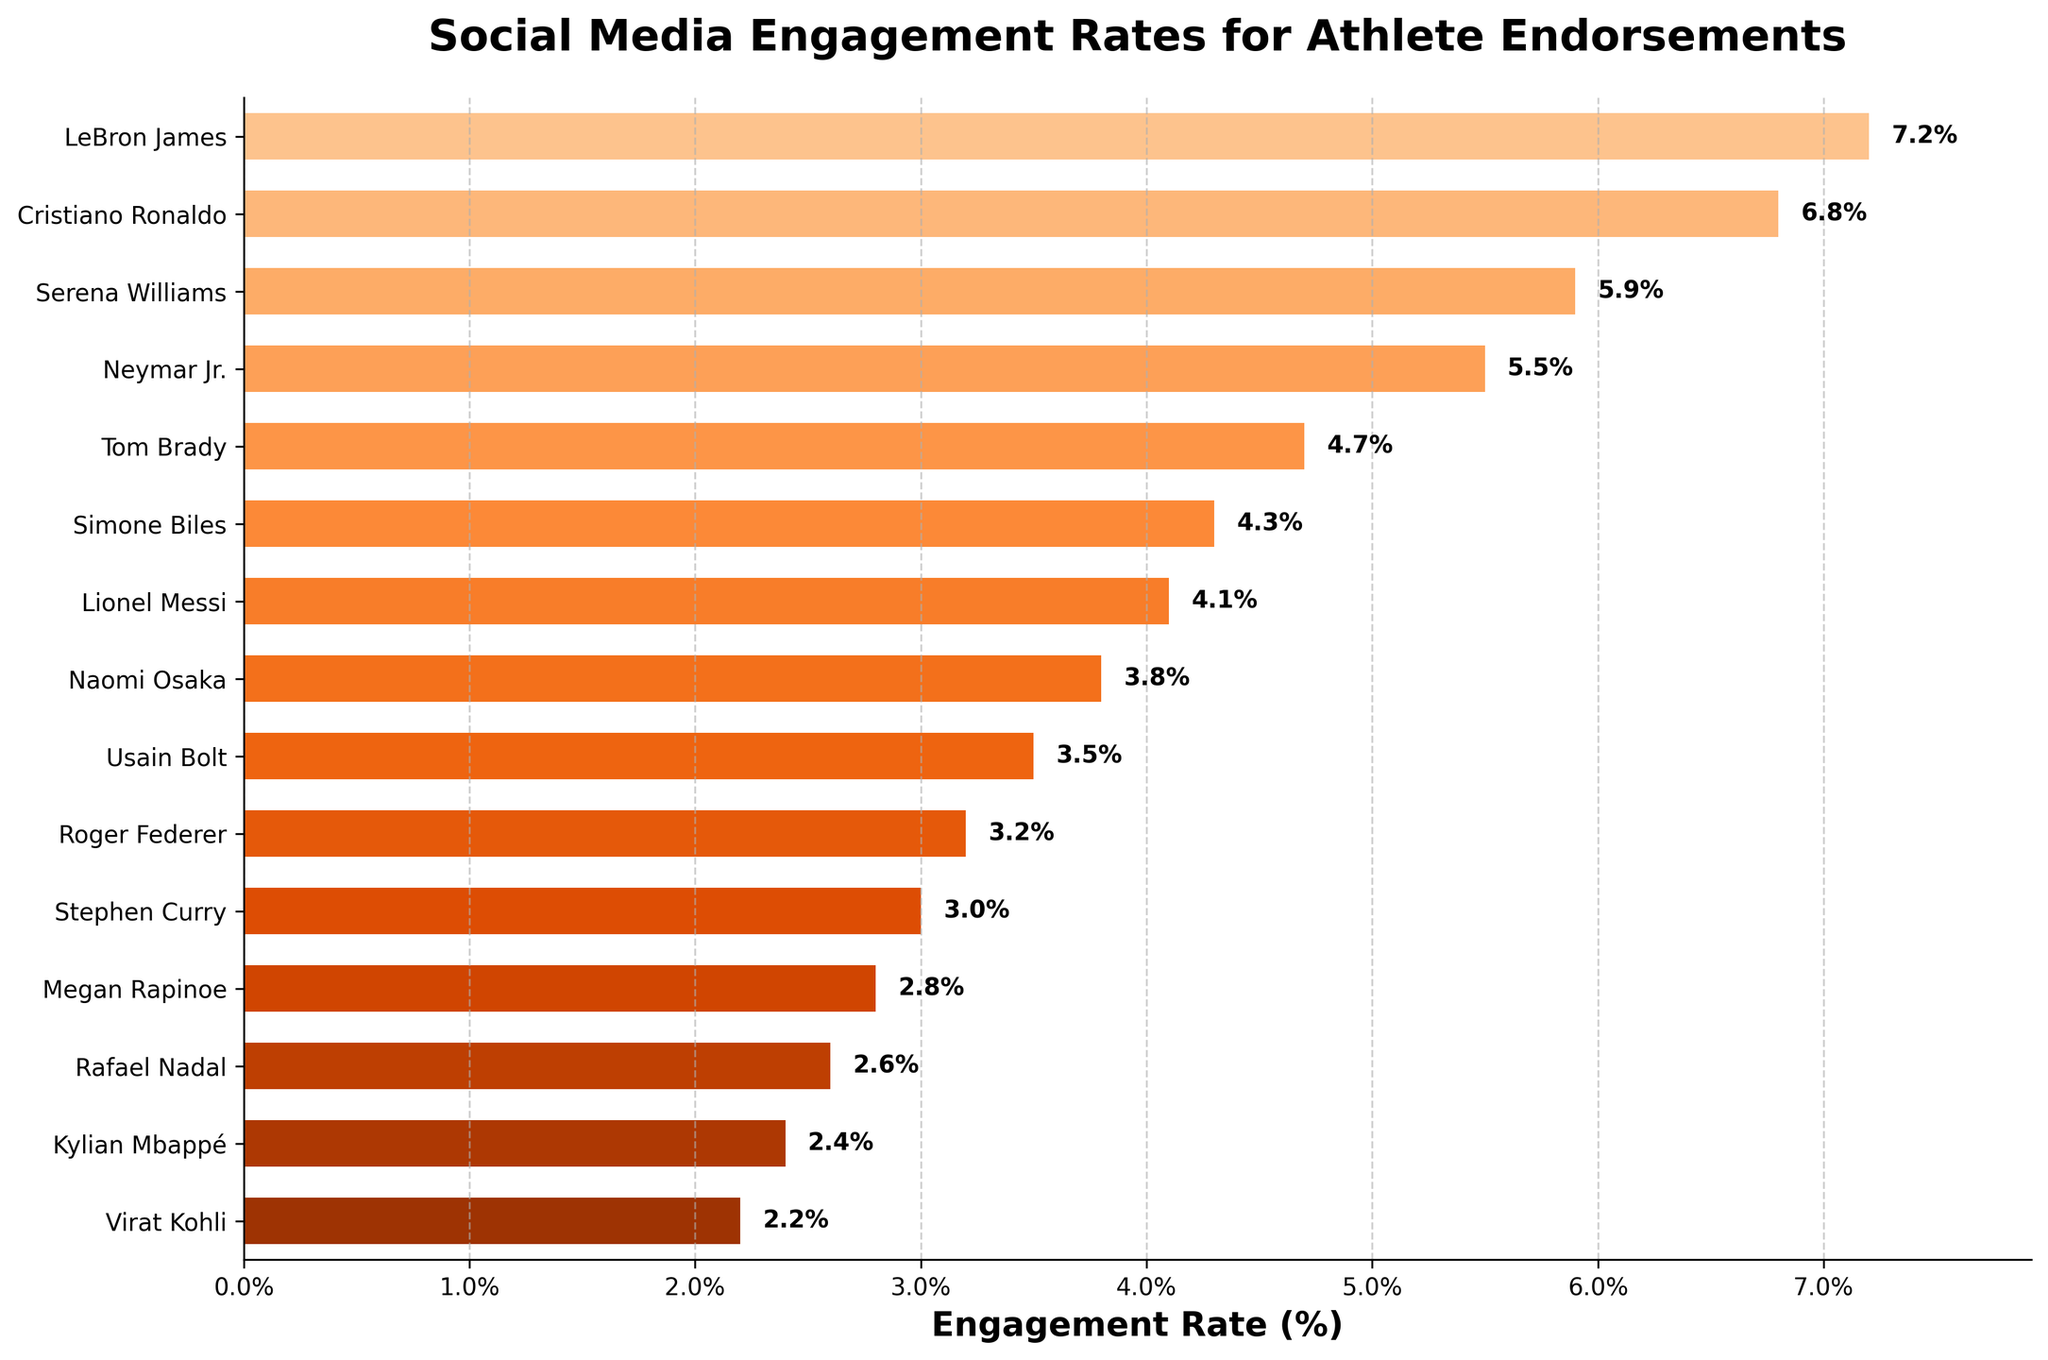What's the engagement rate for Naomi Osaka? To find Naomi Osaka's engagement rate, locate her name on the y-axis and follow horizontally to the corresponding bar. The value is labeled at the end of the bar.
Answer: 3.8% Which athlete has the highest engagement rate? To determine the highest engagement rate, look for the longest bar in the chart. LeBron James has the longest bar.
Answer: LeBron James Who has a higher engagement rate, Serena Williams or Tom Brady? Compare the lengths of the bars for Serena Williams and Tom Brady. Serena Williams' bar is longer.
Answer: Serena Williams What is the difference in engagement rate between Cristiano Ronaldo and Lionel Messi? Locate the bars for Cristiano Ronaldo and Lionel Messi, and subtract Messi's rate (4.1%) from Ronaldo's rate (6.8%).
Answer: 2.7% What's the average engagement rate of the top 5 athletes? Identify the top 5 athletes (LeBron James, Cristiano Ronaldo, Serena Williams, Neymar Jr., Tom Brady) and their rates (7.2, 6.8, 5.9, 5.5, 4.7). Sum these rates and divide by 5: (7.2 + 6.8 + 5.9 + 5.5 + 4.7) / 5 = 30.1 / 5.
Answer: 6.02 How many athletes have an engagement rate higher than 5%? Count the number of bars extending beyond the 5% mark: LeBron James, Cristiano Ronaldo, Serena Williams, and Neymar Jr. There are 4 athletes.
Answer: 4 If Serena Williams' engagement rate increased by 1%, would she still be ranked 3rd? Add 1% to Serena Williams' current rate (5.9% + 1% = 6.9%). Compare this new rate with Cristiano Ronaldo (6.8%) and LeBron James (7.2%). She would rank 2nd.
Answer: No Which athlete has the lowest engagement rate, and what is it? Find the shortest bar on the chart, which belongs to Virat Kohli.
Answer: Virat Kohli, 2.2% What is the average engagement rate across all athletes? Sum all the engagement rates and divide by the total number of athletes (15). Total = 7.2 + 6.8 + 5.9 + 5.5 + 4.7 + 4.3 + 4.1 + 3.8 + 3.5 + 3.2 + 3.0 + 2.8 + 2.6 + 2.4 + 2.2 = 61.0. Average = 61.0 / 15.
Answer: 4.07 Who has a lower engagement rate: Megan Rapinoe or Rafael Nadal? Locate the bars for Megan Rapinoe (2.8%) and Rafael Nadal (2.6%) and compare their lengths. Nadal's bar is shorter than Rapinoe's.
Answer: Rafael Nadal 